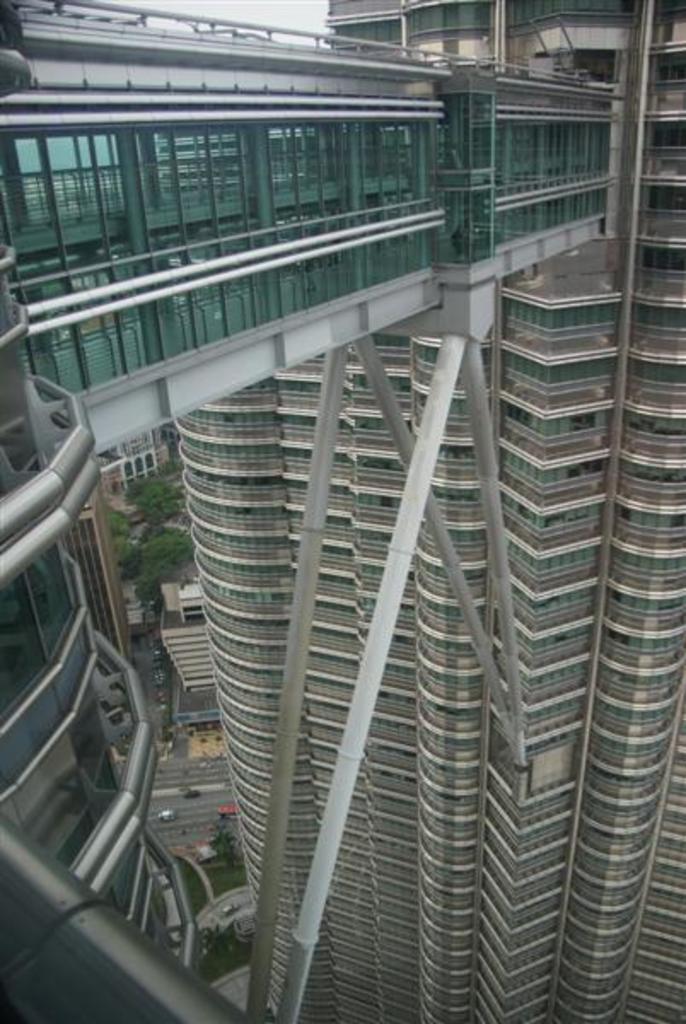Can you describe this image briefly? In the image we can see there are buildings and there is a bridge attached to the building. There are vehicles parked on the road and there are trees. 